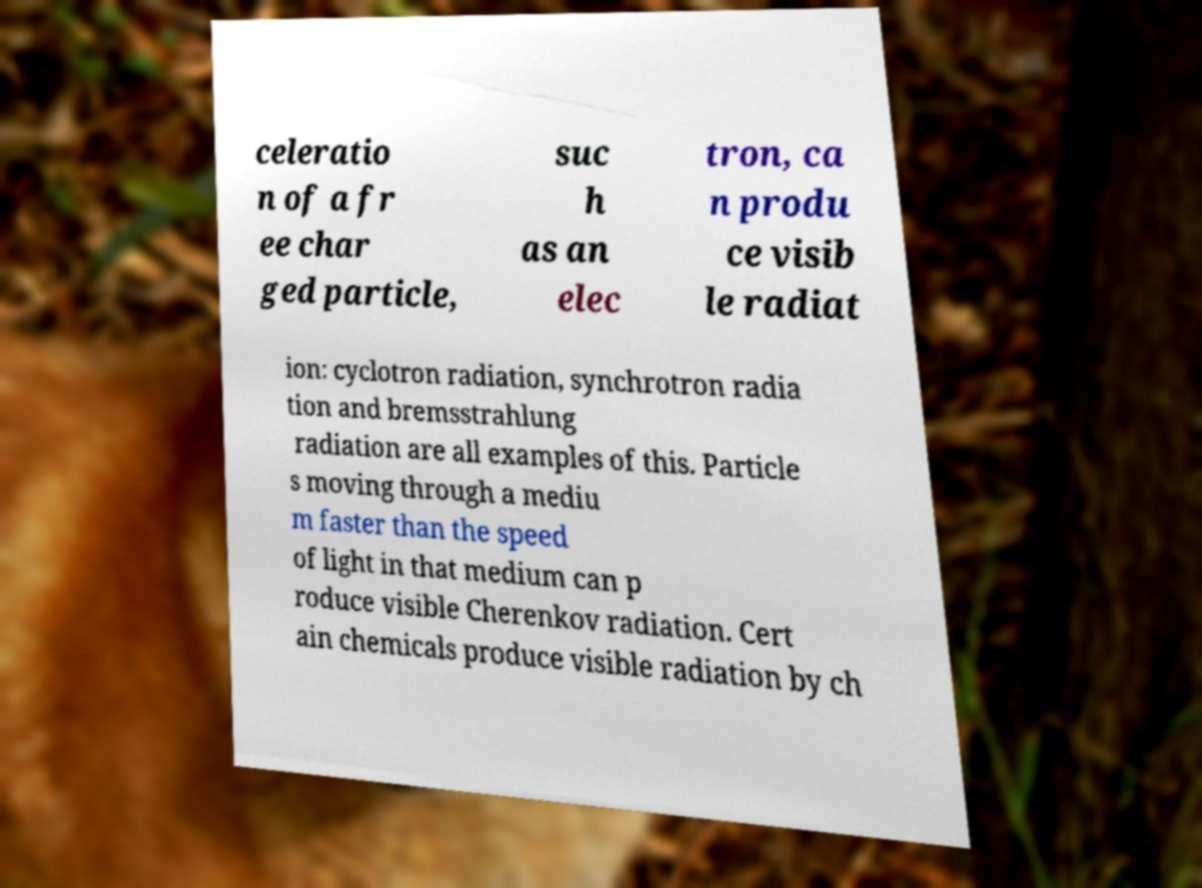Could you extract and type out the text from this image? celeratio n of a fr ee char ged particle, suc h as an elec tron, ca n produ ce visib le radiat ion: cyclotron radiation, synchrotron radia tion and bremsstrahlung radiation are all examples of this. Particle s moving through a mediu m faster than the speed of light in that medium can p roduce visible Cherenkov radiation. Cert ain chemicals produce visible radiation by ch 